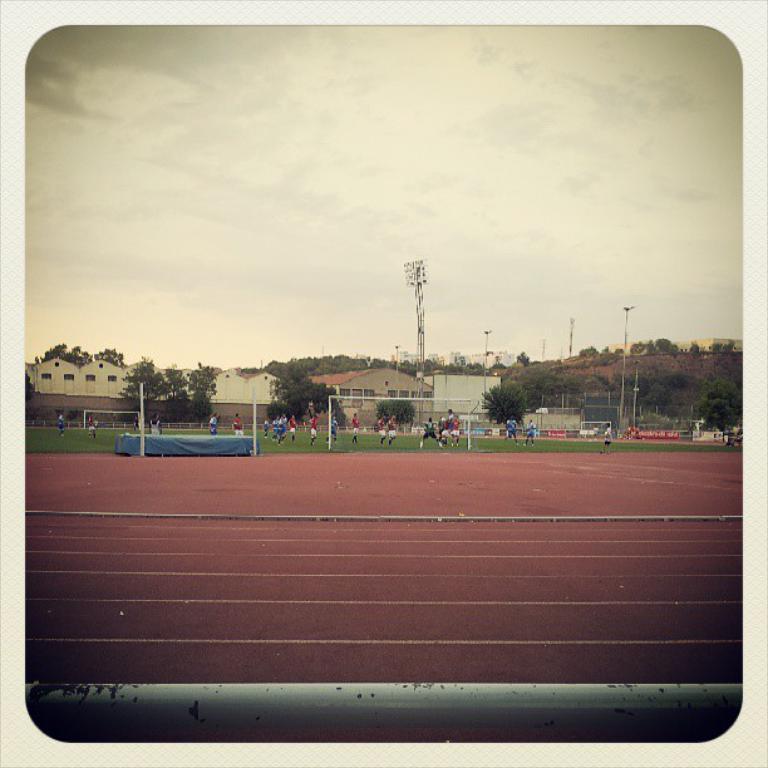Can you describe this image briefly? In this image I can see few players wearing different color dresses. I can see few poles, boards, trees, buildings, windows and the sky. 